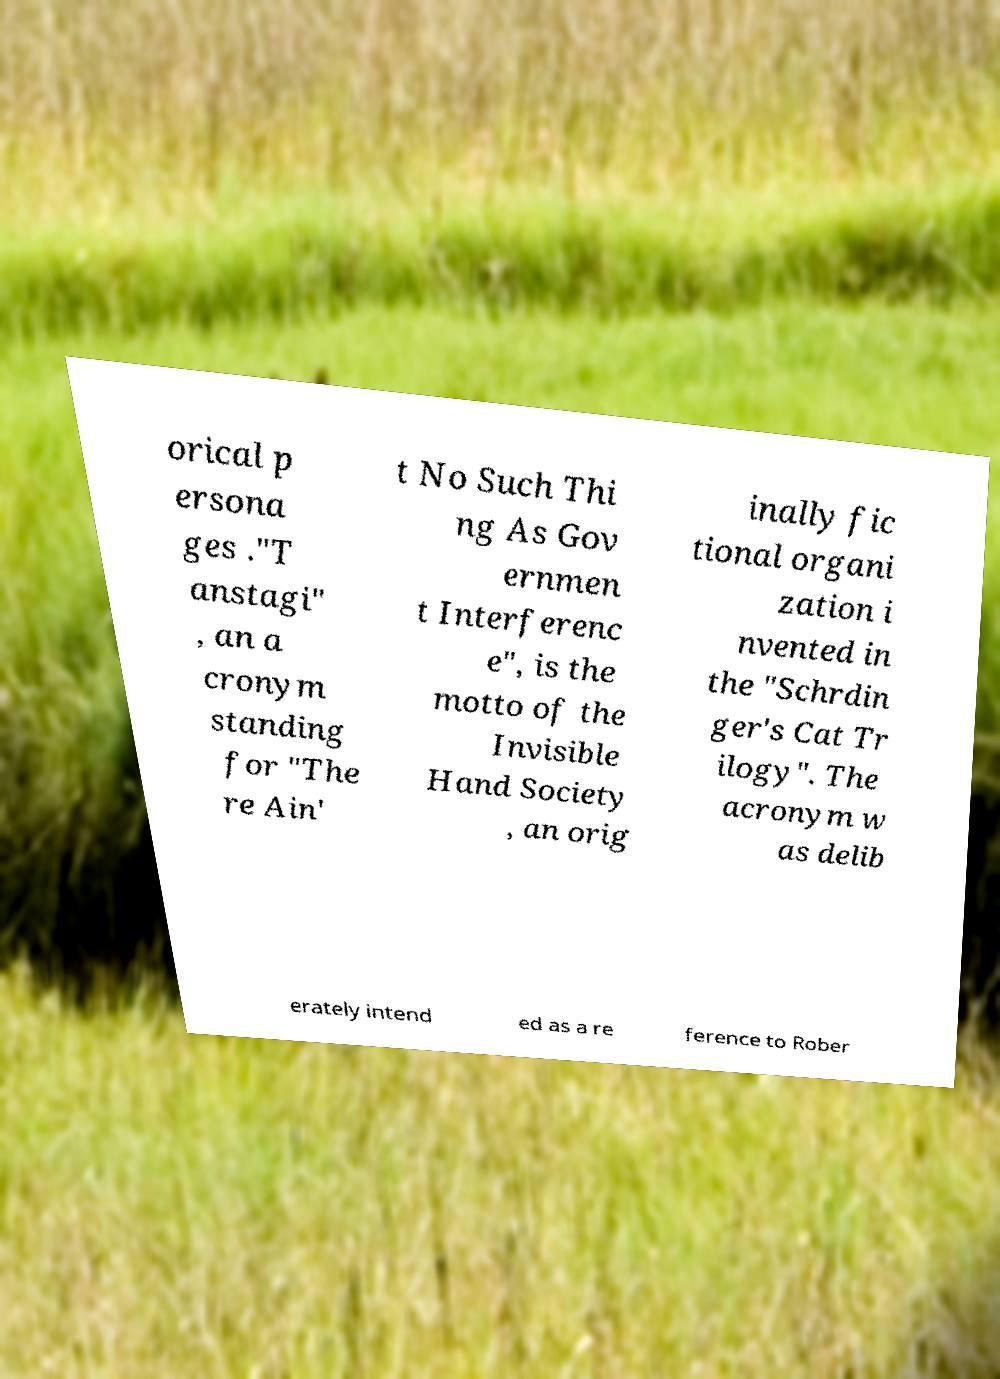Could you extract and type out the text from this image? orical p ersona ges ."T anstagi" , an a cronym standing for "The re Ain' t No Such Thi ng As Gov ernmen t Interferenc e", is the motto of the Invisible Hand Society , an orig inally fic tional organi zation i nvented in the "Schrdin ger's Cat Tr ilogy". The acronym w as delib erately intend ed as a re ference to Rober 